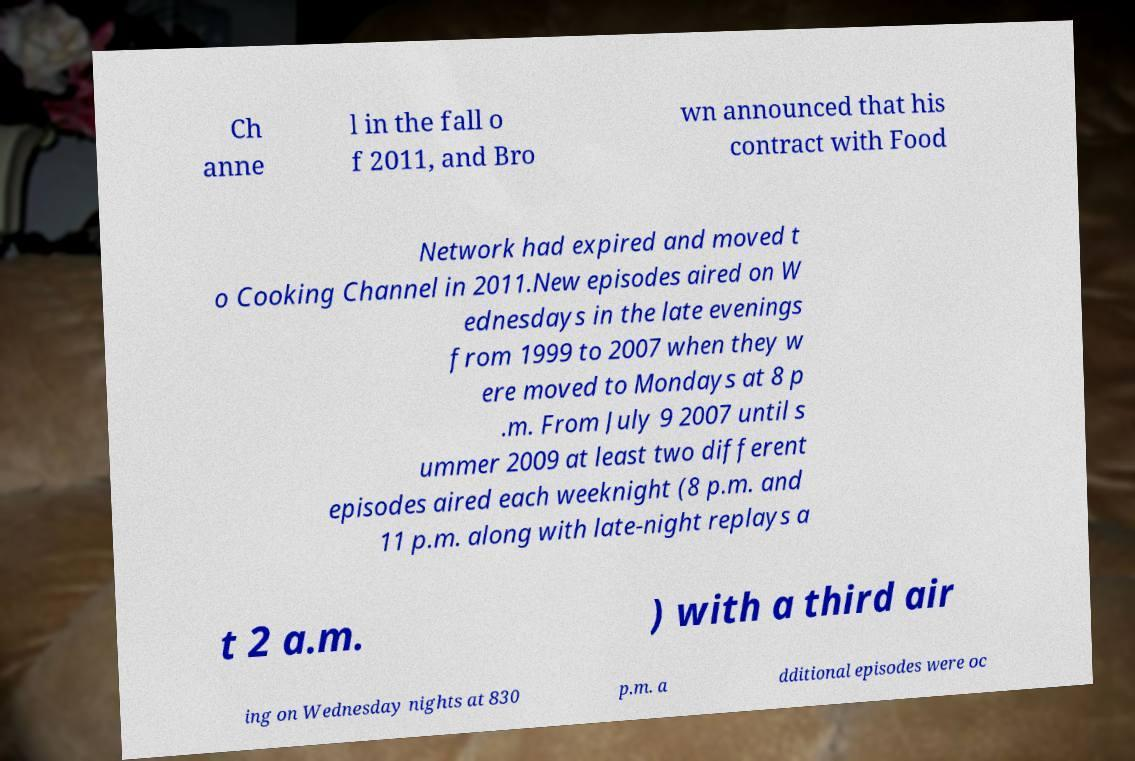Can you accurately transcribe the text from the provided image for me? Ch anne l in the fall o f 2011, and Bro wn announced that his contract with Food Network had expired and moved t o Cooking Channel in 2011.New episodes aired on W ednesdays in the late evenings from 1999 to 2007 when they w ere moved to Mondays at 8 p .m. From July 9 2007 until s ummer 2009 at least two different episodes aired each weeknight (8 p.m. and 11 p.m. along with late-night replays a t 2 a.m. ) with a third air ing on Wednesday nights at 830 p.m. a dditional episodes were oc 